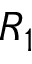Convert formula to latex. <formula><loc_0><loc_0><loc_500><loc_500>R _ { 1 }</formula> 